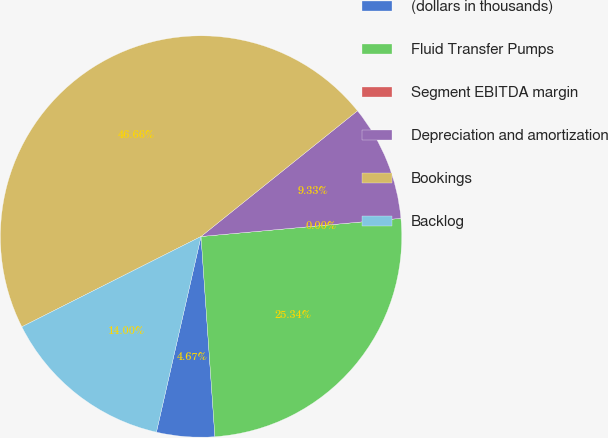Convert chart to OTSL. <chart><loc_0><loc_0><loc_500><loc_500><pie_chart><fcel>(dollars in thousands)<fcel>Fluid Transfer Pumps<fcel>Segment EBITDA margin<fcel>Depreciation and amortization<fcel>Bookings<fcel>Backlog<nl><fcel>4.67%<fcel>25.34%<fcel>0.0%<fcel>9.33%<fcel>46.66%<fcel>14.0%<nl></chart> 